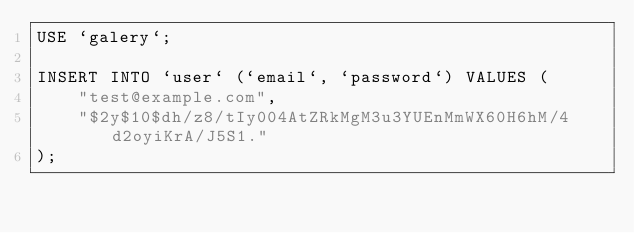<code> <loc_0><loc_0><loc_500><loc_500><_SQL_>USE `galery`;

INSERT INTO `user` (`email`, `password`) VALUES (
    "test@example.com",
    "$2y$10$dh/z8/tIy004AtZRkMgM3u3YUEnMmWX60H6hM/4d2oyiKrA/J5S1."
);
</code> 